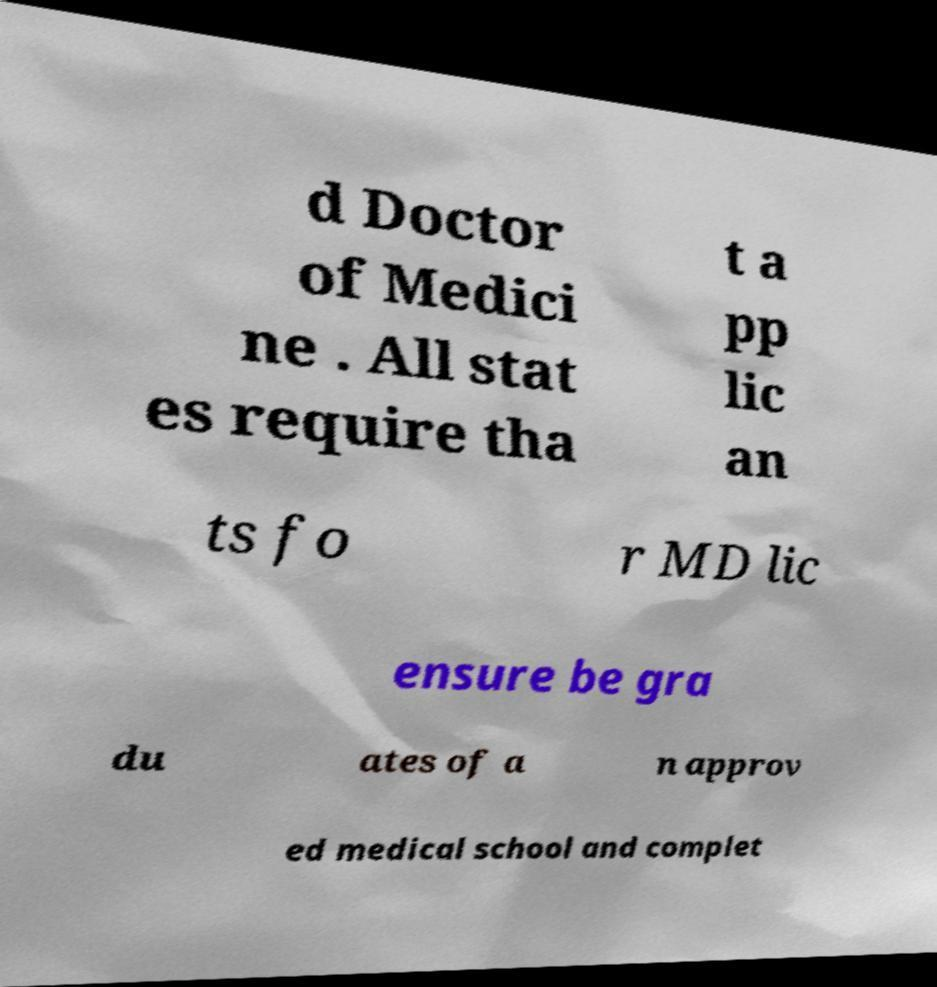Could you assist in decoding the text presented in this image and type it out clearly? d Doctor of Medici ne . All stat es require tha t a pp lic an ts fo r MD lic ensure be gra du ates of a n approv ed medical school and complet 